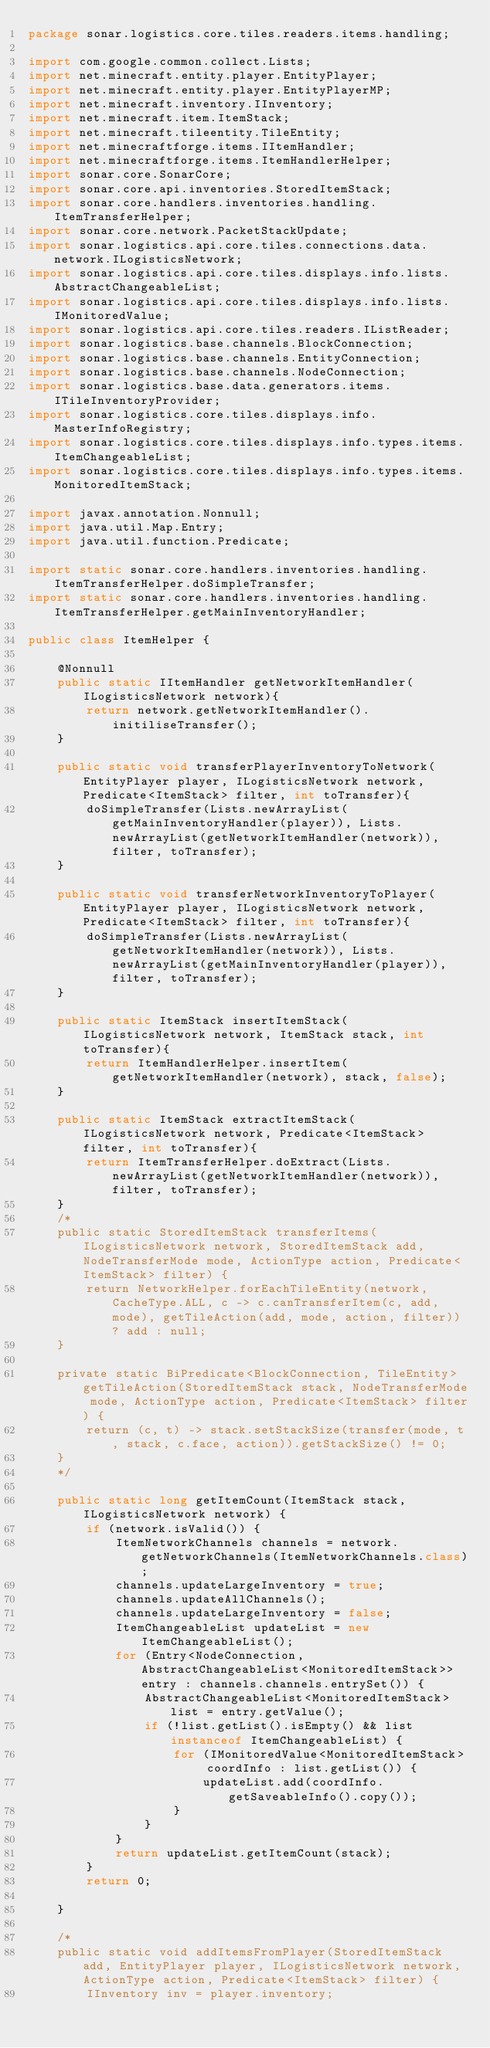<code> <loc_0><loc_0><loc_500><loc_500><_Java_>package sonar.logistics.core.tiles.readers.items.handling;

import com.google.common.collect.Lists;
import net.minecraft.entity.player.EntityPlayer;
import net.minecraft.entity.player.EntityPlayerMP;
import net.minecraft.inventory.IInventory;
import net.minecraft.item.ItemStack;
import net.minecraft.tileentity.TileEntity;
import net.minecraftforge.items.IItemHandler;
import net.minecraftforge.items.ItemHandlerHelper;
import sonar.core.SonarCore;
import sonar.core.api.inventories.StoredItemStack;
import sonar.core.handlers.inventories.handling.ItemTransferHelper;
import sonar.core.network.PacketStackUpdate;
import sonar.logistics.api.core.tiles.connections.data.network.ILogisticsNetwork;
import sonar.logistics.api.core.tiles.displays.info.lists.AbstractChangeableList;
import sonar.logistics.api.core.tiles.displays.info.lists.IMonitoredValue;
import sonar.logistics.api.core.tiles.readers.IListReader;
import sonar.logistics.base.channels.BlockConnection;
import sonar.logistics.base.channels.EntityConnection;
import sonar.logistics.base.channels.NodeConnection;
import sonar.logistics.base.data.generators.items.ITileInventoryProvider;
import sonar.logistics.core.tiles.displays.info.MasterInfoRegistry;
import sonar.logistics.core.tiles.displays.info.types.items.ItemChangeableList;
import sonar.logistics.core.tiles.displays.info.types.items.MonitoredItemStack;

import javax.annotation.Nonnull;
import java.util.Map.Entry;
import java.util.function.Predicate;

import static sonar.core.handlers.inventories.handling.ItemTransferHelper.doSimpleTransfer;
import static sonar.core.handlers.inventories.handling.ItemTransferHelper.getMainInventoryHandler;

public class ItemHelper {

	@Nonnull
	public static IItemHandler getNetworkItemHandler(ILogisticsNetwork network){
		return network.getNetworkItemHandler().initiliseTransfer();
	}

	public static void transferPlayerInventoryToNetwork(EntityPlayer player, ILogisticsNetwork network, Predicate<ItemStack> filter, int toTransfer){
		doSimpleTransfer(Lists.newArrayList(getMainInventoryHandler(player)), Lists.newArrayList(getNetworkItemHandler(network)), filter, toTransfer);
	}

	public static void transferNetworkInventoryToPlayer(EntityPlayer player, ILogisticsNetwork network, Predicate<ItemStack> filter, int toTransfer){
		doSimpleTransfer(Lists.newArrayList(getNetworkItemHandler(network)), Lists.newArrayList(getMainInventoryHandler(player)), filter, toTransfer);
	}

	public static ItemStack insertItemStack(ILogisticsNetwork network, ItemStack stack, int toTransfer){
		return ItemHandlerHelper.insertItem(getNetworkItemHandler(network), stack, false);
	}

	public static ItemStack extractItemStack(ILogisticsNetwork network, Predicate<ItemStack> filter, int toTransfer){
		return ItemTransferHelper.doExtract(Lists.newArrayList(getNetworkItemHandler(network)), filter, toTransfer);
	}
	/*
	public static StoredItemStack transferItems(ILogisticsNetwork network, StoredItemStack add, NodeTransferMode mode, ActionType action, Predicate<ItemStack> filter) {
		return NetworkHelper.forEachTileEntity(network, CacheType.ALL, c -> c.canTransferItem(c, add, mode), getTileAction(add, mode, action, filter)) ? add : null;
	}

	private static BiPredicate<BlockConnection, TileEntity> getTileAction(StoredItemStack stack, NodeTransferMode mode, ActionType action, Predicate<ItemStack> filter) {
		return (c, t) -> stack.setStackSize(transfer(mode, t, stack, c.face, action)).getStackSize() != 0;
	}
	*/

	public static long getItemCount(ItemStack stack, ILogisticsNetwork network) {
		if (network.isValid()) {
			ItemNetworkChannels channels = network.getNetworkChannels(ItemNetworkChannels.class);
			channels.updateLargeInventory = true;
			channels.updateAllChannels();
			channels.updateLargeInventory = false;
			ItemChangeableList updateList = new ItemChangeableList();
			for (Entry<NodeConnection, AbstractChangeableList<MonitoredItemStack>> entry : channels.channels.entrySet()) {
				AbstractChangeableList<MonitoredItemStack> list = entry.getValue();
				if (!list.getList().isEmpty() && list instanceof ItemChangeableList) {
					for (IMonitoredValue<MonitoredItemStack> coordInfo : list.getList()) {
						updateList.add(coordInfo.getSaveableInfo().copy());
					}
				}
			}
			return updateList.getItemCount(stack);
		}
		return 0;

	}

	/*
	public static void addItemsFromPlayer(StoredItemStack add, EntityPlayer player, ILogisticsNetwork network, ActionType action, Predicate<ItemStack> filter) {
		IInventory inv = player.inventory;</code> 